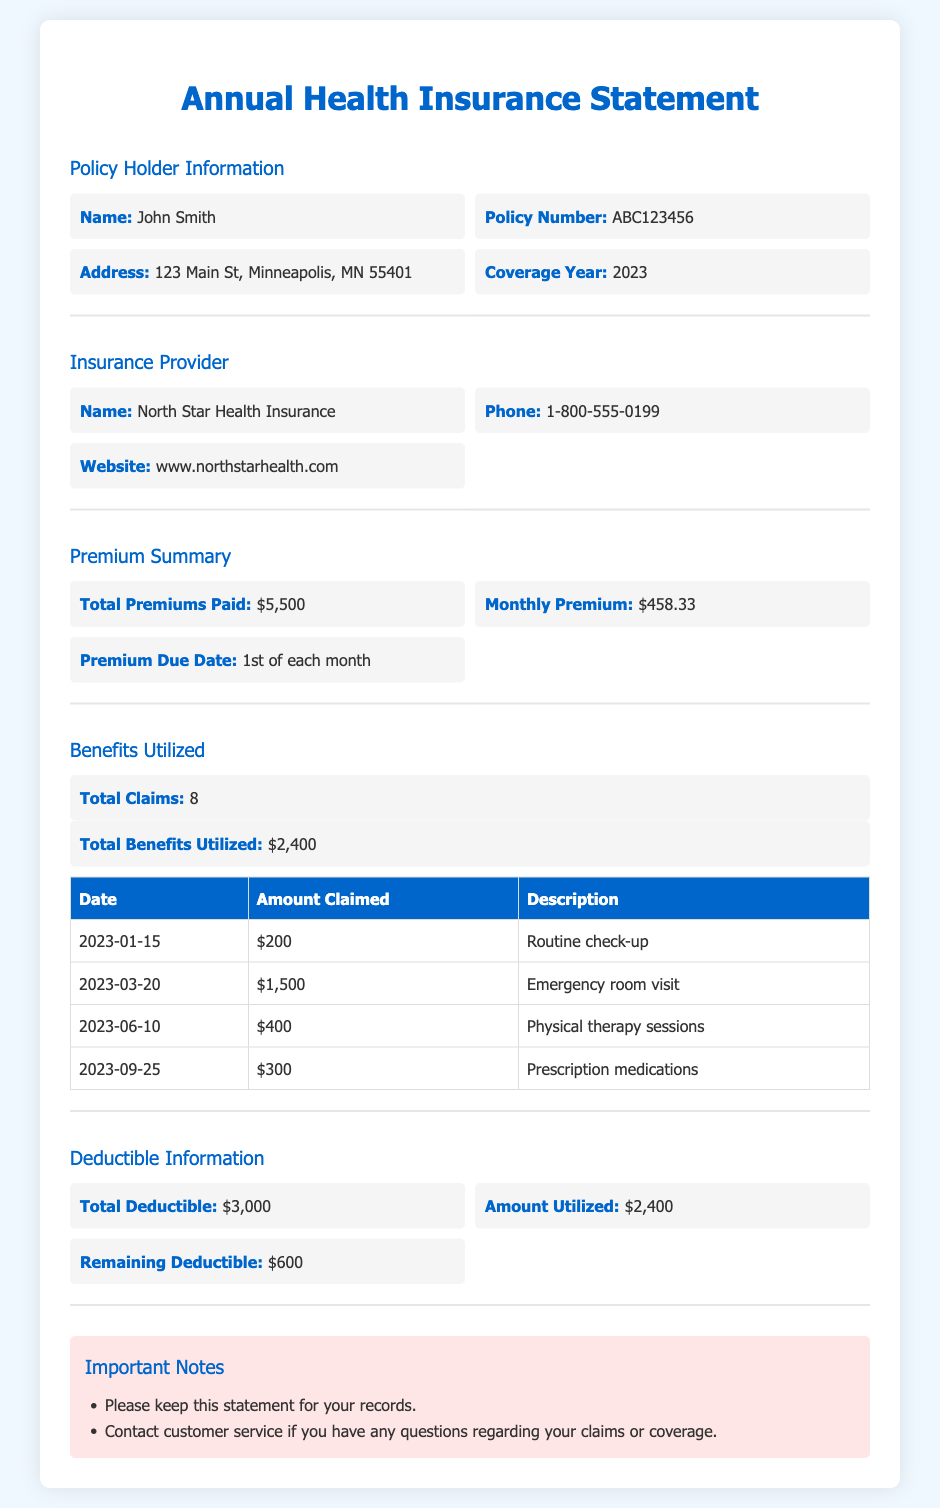What is the total premiums paid? The total premiums paid is listed directly in the document, which is $5,500.
Answer: $5,500 Who is the policy holder? The policy holder's name is provided at the beginning of the document, which is John Smith.
Answer: John Smith What is the remaining deductible? The remaining deductible is specified in the deductibles section of the document, which is $600.
Answer: $600 How many total claims were made? The document states the total number of claims, which is 8.
Answer: 8 What is the premium due date? The document indicates that the premium is due on the 1st of each month.
Answer: 1st of each month What was the total benefits utilized? The total benefits utilized is clearly mentioned in the benefits section, which is $2,400.
Answer: $2,400 What is the name of the insurance provider? The insurance provider's name is listed in the corresponding section of the document as North Star Health Insurance.
Answer: North Star Health Insurance How much was claimed on the emergency room visit? The amount claimed for the emergency room visit can be found in the claims table, which is $1,500.
Answer: $1,500 What is the total deductible? The total deductible is outlined in the deductible information section, which is $3,000.
Answer: $3,000 